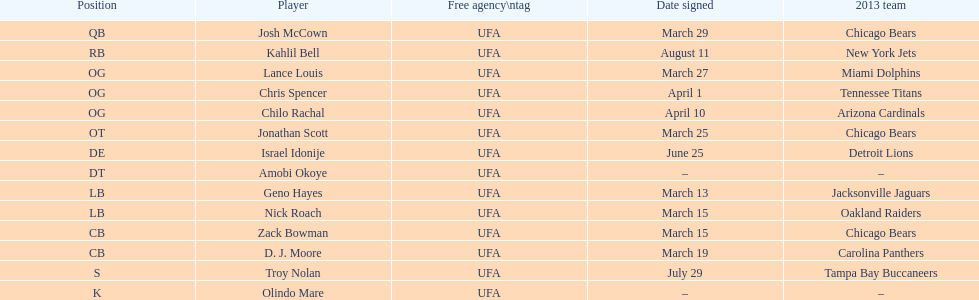Nick roach was signed the same day as what other player? Zack Bowman. 